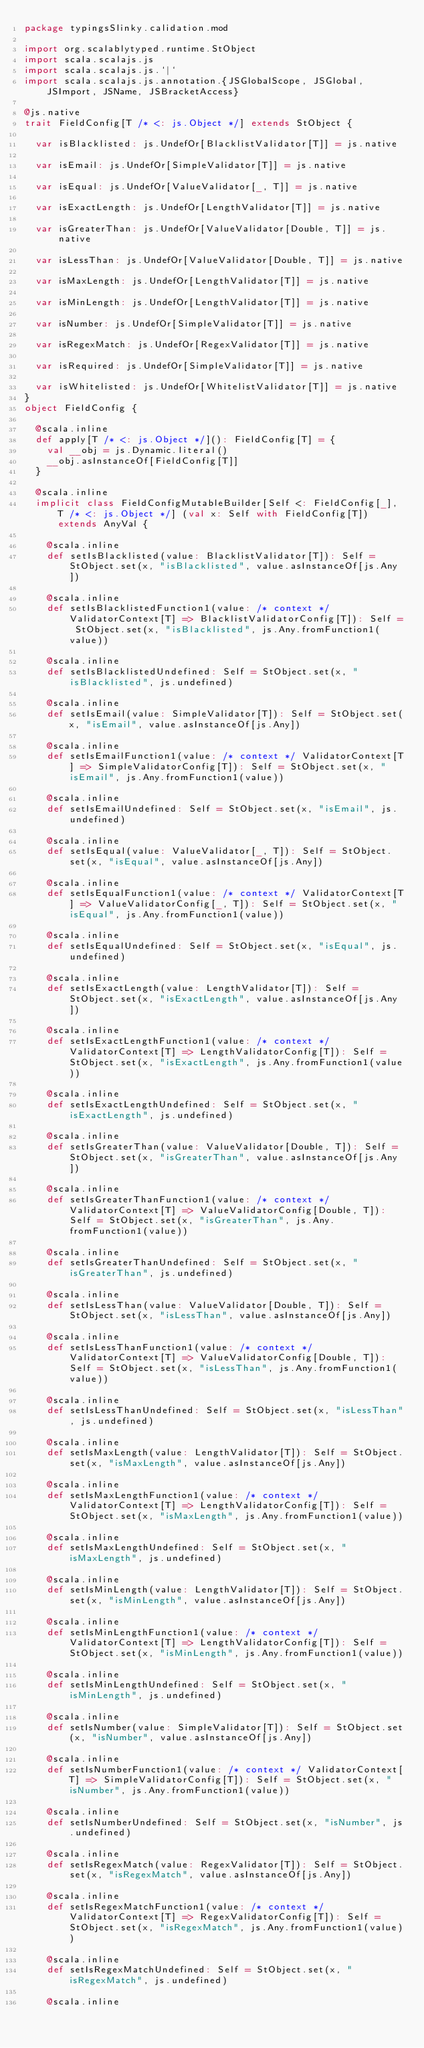<code> <loc_0><loc_0><loc_500><loc_500><_Scala_>package typingsSlinky.calidation.mod

import org.scalablytyped.runtime.StObject
import scala.scalajs.js
import scala.scalajs.js.`|`
import scala.scalajs.js.annotation.{JSGlobalScope, JSGlobal, JSImport, JSName, JSBracketAccess}

@js.native
trait FieldConfig[T /* <: js.Object */] extends StObject {
  
  var isBlacklisted: js.UndefOr[BlacklistValidator[T]] = js.native
  
  var isEmail: js.UndefOr[SimpleValidator[T]] = js.native
  
  var isEqual: js.UndefOr[ValueValidator[_, T]] = js.native
  
  var isExactLength: js.UndefOr[LengthValidator[T]] = js.native
  
  var isGreaterThan: js.UndefOr[ValueValidator[Double, T]] = js.native
  
  var isLessThan: js.UndefOr[ValueValidator[Double, T]] = js.native
  
  var isMaxLength: js.UndefOr[LengthValidator[T]] = js.native
  
  var isMinLength: js.UndefOr[LengthValidator[T]] = js.native
  
  var isNumber: js.UndefOr[SimpleValidator[T]] = js.native
  
  var isRegexMatch: js.UndefOr[RegexValidator[T]] = js.native
  
  var isRequired: js.UndefOr[SimpleValidator[T]] = js.native
  
  var isWhitelisted: js.UndefOr[WhitelistValidator[T]] = js.native
}
object FieldConfig {
  
  @scala.inline
  def apply[T /* <: js.Object */](): FieldConfig[T] = {
    val __obj = js.Dynamic.literal()
    __obj.asInstanceOf[FieldConfig[T]]
  }
  
  @scala.inline
  implicit class FieldConfigMutableBuilder[Self <: FieldConfig[_], T /* <: js.Object */] (val x: Self with FieldConfig[T]) extends AnyVal {
    
    @scala.inline
    def setIsBlacklisted(value: BlacklistValidator[T]): Self = StObject.set(x, "isBlacklisted", value.asInstanceOf[js.Any])
    
    @scala.inline
    def setIsBlacklistedFunction1(value: /* context */ ValidatorContext[T] => BlacklistValidatorConfig[T]): Self = StObject.set(x, "isBlacklisted", js.Any.fromFunction1(value))
    
    @scala.inline
    def setIsBlacklistedUndefined: Self = StObject.set(x, "isBlacklisted", js.undefined)
    
    @scala.inline
    def setIsEmail(value: SimpleValidator[T]): Self = StObject.set(x, "isEmail", value.asInstanceOf[js.Any])
    
    @scala.inline
    def setIsEmailFunction1(value: /* context */ ValidatorContext[T] => SimpleValidatorConfig[T]): Self = StObject.set(x, "isEmail", js.Any.fromFunction1(value))
    
    @scala.inline
    def setIsEmailUndefined: Self = StObject.set(x, "isEmail", js.undefined)
    
    @scala.inline
    def setIsEqual(value: ValueValidator[_, T]): Self = StObject.set(x, "isEqual", value.asInstanceOf[js.Any])
    
    @scala.inline
    def setIsEqualFunction1(value: /* context */ ValidatorContext[T] => ValueValidatorConfig[_, T]): Self = StObject.set(x, "isEqual", js.Any.fromFunction1(value))
    
    @scala.inline
    def setIsEqualUndefined: Self = StObject.set(x, "isEqual", js.undefined)
    
    @scala.inline
    def setIsExactLength(value: LengthValidator[T]): Self = StObject.set(x, "isExactLength", value.asInstanceOf[js.Any])
    
    @scala.inline
    def setIsExactLengthFunction1(value: /* context */ ValidatorContext[T] => LengthValidatorConfig[T]): Self = StObject.set(x, "isExactLength", js.Any.fromFunction1(value))
    
    @scala.inline
    def setIsExactLengthUndefined: Self = StObject.set(x, "isExactLength", js.undefined)
    
    @scala.inline
    def setIsGreaterThan(value: ValueValidator[Double, T]): Self = StObject.set(x, "isGreaterThan", value.asInstanceOf[js.Any])
    
    @scala.inline
    def setIsGreaterThanFunction1(value: /* context */ ValidatorContext[T] => ValueValidatorConfig[Double, T]): Self = StObject.set(x, "isGreaterThan", js.Any.fromFunction1(value))
    
    @scala.inline
    def setIsGreaterThanUndefined: Self = StObject.set(x, "isGreaterThan", js.undefined)
    
    @scala.inline
    def setIsLessThan(value: ValueValidator[Double, T]): Self = StObject.set(x, "isLessThan", value.asInstanceOf[js.Any])
    
    @scala.inline
    def setIsLessThanFunction1(value: /* context */ ValidatorContext[T] => ValueValidatorConfig[Double, T]): Self = StObject.set(x, "isLessThan", js.Any.fromFunction1(value))
    
    @scala.inline
    def setIsLessThanUndefined: Self = StObject.set(x, "isLessThan", js.undefined)
    
    @scala.inline
    def setIsMaxLength(value: LengthValidator[T]): Self = StObject.set(x, "isMaxLength", value.asInstanceOf[js.Any])
    
    @scala.inline
    def setIsMaxLengthFunction1(value: /* context */ ValidatorContext[T] => LengthValidatorConfig[T]): Self = StObject.set(x, "isMaxLength", js.Any.fromFunction1(value))
    
    @scala.inline
    def setIsMaxLengthUndefined: Self = StObject.set(x, "isMaxLength", js.undefined)
    
    @scala.inline
    def setIsMinLength(value: LengthValidator[T]): Self = StObject.set(x, "isMinLength", value.asInstanceOf[js.Any])
    
    @scala.inline
    def setIsMinLengthFunction1(value: /* context */ ValidatorContext[T] => LengthValidatorConfig[T]): Self = StObject.set(x, "isMinLength", js.Any.fromFunction1(value))
    
    @scala.inline
    def setIsMinLengthUndefined: Self = StObject.set(x, "isMinLength", js.undefined)
    
    @scala.inline
    def setIsNumber(value: SimpleValidator[T]): Self = StObject.set(x, "isNumber", value.asInstanceOf[js.Any])
    
    @scala.inline
    def setIsNumberFunction1(value: /* context */ ValidatorContext[T] => SimpleValidatorConfig[T]): Self = StObject.set(x, "isNumber", js.Any.fromFunction1(value))
    
    @scala.inline
    def setIsNumberUndefined: Self = StObject.set(x, "isNumber", js.undefined)
    
    @scala.inline
    def setIsRegexMatch(value: RegexValidator[T]): Self = StObject.set(x, "isRegexMatch", value.asInstanceOf[js.Any])
    
    @scala.inline
    def setIsRegexMatchFunction1(value: /* context */ ValidatorContext[T] => RegexValidatorConfig[T]): Self = StObject.set(x, "isRegexMatch", js.Any.fromFunction1(value))
    
    @scala.inline
    def setIsRegexMatchUndefined: Self = StObject.set(x, "isRegexMatch", js.undefined)
    
    @scala.inline</code> 